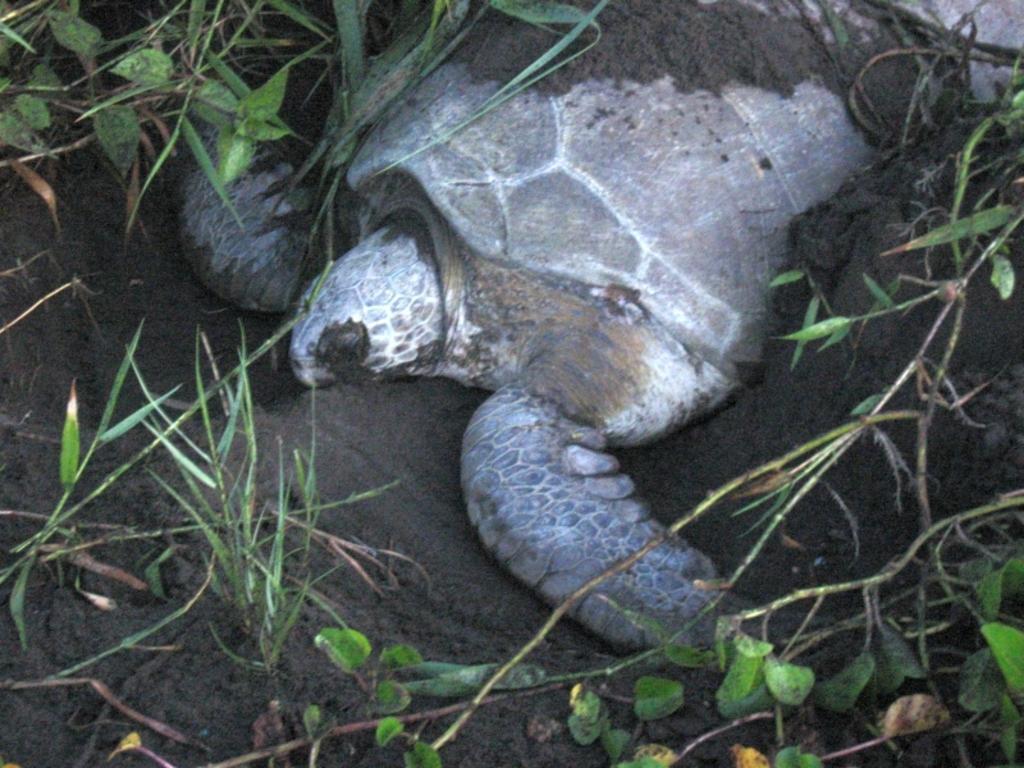Could you give a brief overview of what you see in this image? In this image I can see the tortoise which is in brown and grey color. To the side I can see the mud and the grass. 